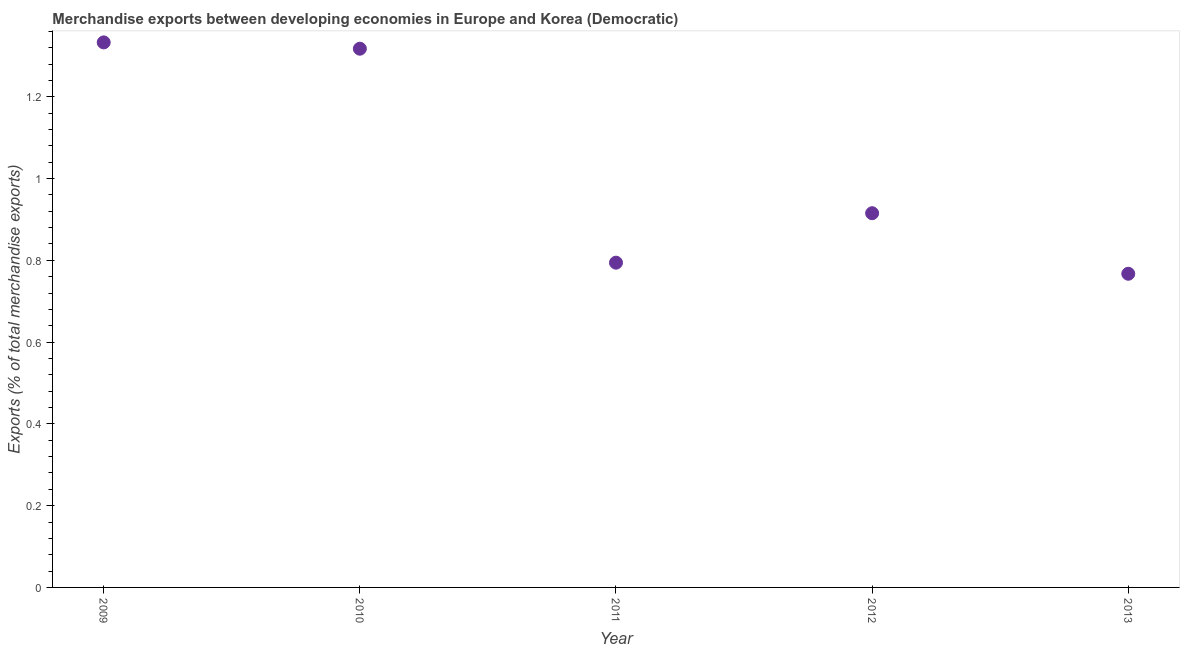What is the merchandise exports in 2012?
Provide a succinct answer. 0.92. Across all years, what is the maximum merchandise exports?
Your answer should be very brief. 1.33. Across all years, what is the minimum merchandise exports?
Offer a terse response. 0.77. In which year was the merchandise exports maximum?
Offer a very short reply. 2009. In which year was the merchandise exports minimum?
Provide a short and direct response. 2013. What is the sum of the merchandise exports?
Give a very brief answer. 5.13. What is the difference between the merchandise exports in 2009 and 2011?
Your answer should be very brief. 0.54. What is the average merchandise exports per year?
Your answer should be compact. 1.03. What is the median merchandise exports?
Offer a terse response. 0.92. What is the ratio of the merchandise exports in 2012 to that in 2013?
Provide a short and direct response. 1.19. Is the difference between the merchandise exports in 2010 and 2012 greater than the difference between any two years?
Provide a succinct answer. No. What is the difference between the highest and the second highest merchandise exports?
Provide a succinct answer. 0.02. What is the difference between the highest and the lowest merchandise exports?
Keep it short and to the point. 0.57. How many dotlines are there?
Ensure brevity in your answer.  1. How many years are there in the graph?
Provide a short and direct response. 5. Are the values on the major ticks of Y-axis written in scientific E-notation?
Keep it short and to the point. No. Does the graph contain any zero values?
Ensure brevity in your answer.  No. Does the graph contain grids?
Provide a succinct answer. No. What is the title of the graph?
Keep it short and to the point. Merchandise exports between developing economies in Europe and Korea (Democratic). What is the label or title of the Y-axis?
Give a very brief answer. Exports (% of total merchandise exports). What is the Exports (% of total merchandise exports) in 2009?
Provide a succinct answer. 1.33. What is the Exports (% of total merchandise exports) in 2010?
Keep it short and to the point. 1.32. What is the Exports (% of total merchandise exports) in 2011?
Offer a very short reply. 0.79. What is the Exports (% of total merchandise exports) in 2012?
Give a very brief answer. 0.92. What is the Exports (% of total merchandise exports) in 2013?
Offer a very short reply. 0.77. What is the difference between the Exports (% of total merchandise exports) in 2009 and 2010?
Your answer should be very brief. 0.02. What is the difference between the Exports (% of total merchandise exports) in 2009 and 2011?
Offer a very short reply. 0.54. What is the difference between the Exports (% of total merchandise exports) in 2009 and 2012?
Make the answer very short. 0.42. What is the difference between the Exports (% of total merchandise exports) in 2009 and 2013?
Your response must be concise. 0.57. What is the difference between the Exports (% of total merchandise exports) in 2010 and 2011?
Provide a succinct answer. 0.52. What is the difference between the Exports (% of total merchandise exports) in 2010 and 2012?
Offer a very short reply. 0.4. What is the difference between the Exports (% of total merchandise exports) in 2010 and 2013?
Offer a very short reply. 0.55. What is the difference between the Exports (% of total merchandise exports) in 2011 and 2012?
Your answer should be compact. -0.12. What is the difference between the Exports (% of total merchandise exports) in 2011 and 2013?
Ensure brevity in your answer.  0.03. What is the difference between the Exports (% of total merchandise exports) in 2012 and 2013?
Ensure brevity in your answer.  0.15. What is the ratio of the Exports (% of total merchandise exports) in 2009 to that in 2011?
Offer a terse response. 1.68. What is the ratio of the Exports (% of total merchandise exports) in 2009 to that in 2012?
Your response must be concise. 1.46. What is the ratio of the Exports (% of total merchandise exports) in 2009 to that in 2013?
Ensure brevity in your answer.  1.74. What is the ratio of the Exports (% of total merchandise exports) in 2010 to that in 2011?
Your response must be concise. 1.66. What is the ratio of the Exports (% of total merchandise exports) in 2010 to that in 2012?
Offer a terse response. 1.44. What is the ratio of the Exports (% of total merchandise exports) in 2010 to that in 2013?
Your answer should be very brief. 1.72. What is the ratio of the Exports (% of total merchandise exports) in 2011 to that in 2012?
Provide a succinct answer. 0.87. What is the ratio of the Exports (% of total merchandise exports) in 2011 to that in 2013?
Give a very brief answer. 1.03. What is the ratio of the Exports (% of total merchandise exports) in 2012 to that in 2013?
Ensure brevity in your answer.  1.19. 